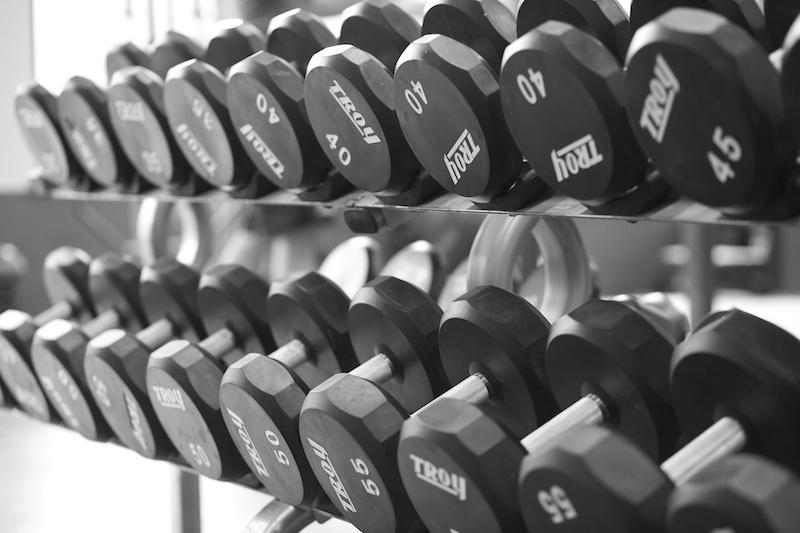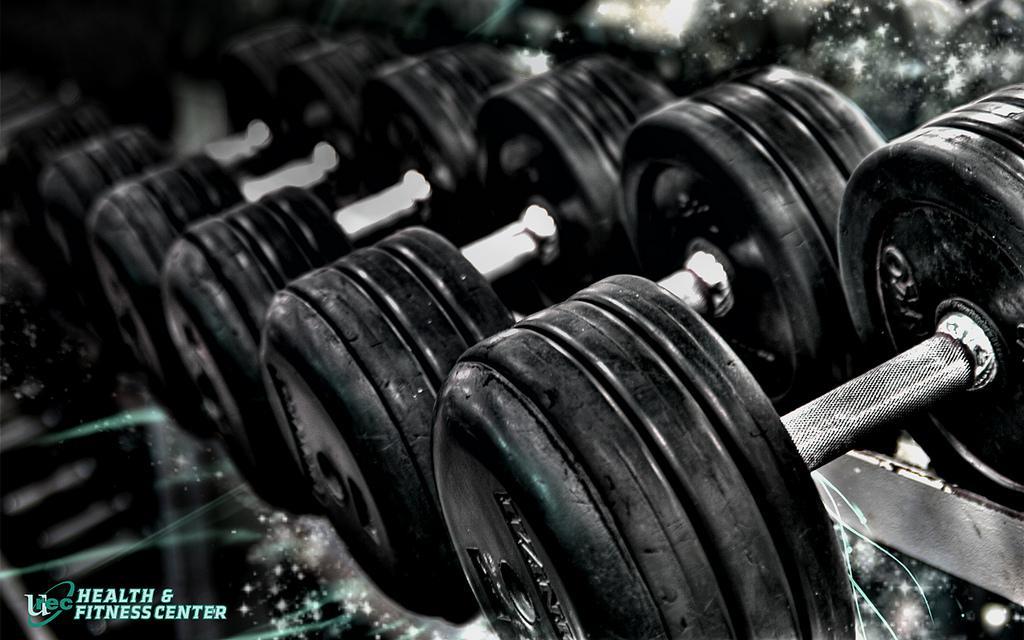The first image is the image on the left, the second image is the image on the right. For the images displayed, is the sentence "The round weights are sitting on the floor in one of the images." factually correct? Answer yes or no. No. The first image is the image on the left, the second image is the image on the right. Assess this claim about the two images: "The dumbbells closest to the camera in one image have beveled edges instead of round edges.". Correct or not? Answer yes or no. Yes. 